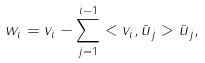<formula> <loc_0><loc_0><loc_500><loc_500>w _ { i } = v _ { i } - \sum _ { j = 1 } ^ { i - 1 } < v _ { i } , \bar { u } _ { j } > \bar { u } _ { j } ,</formula> 